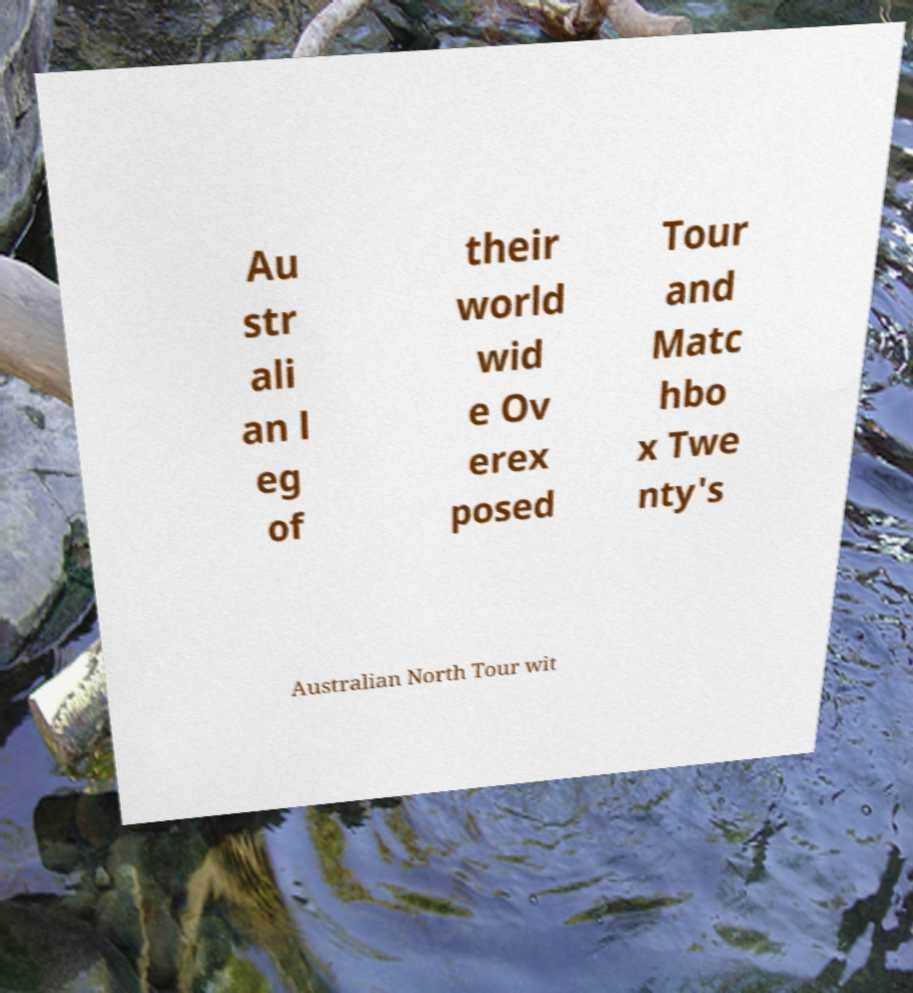Can you read and provide the text displayed in the image?This photo seems to have some interesting text. Can you extract and type it out for me? Au str ali an l eg of their world wid e Ov erex posed Tour and Matc hbo x Twe nty's Australian North Tour wit 